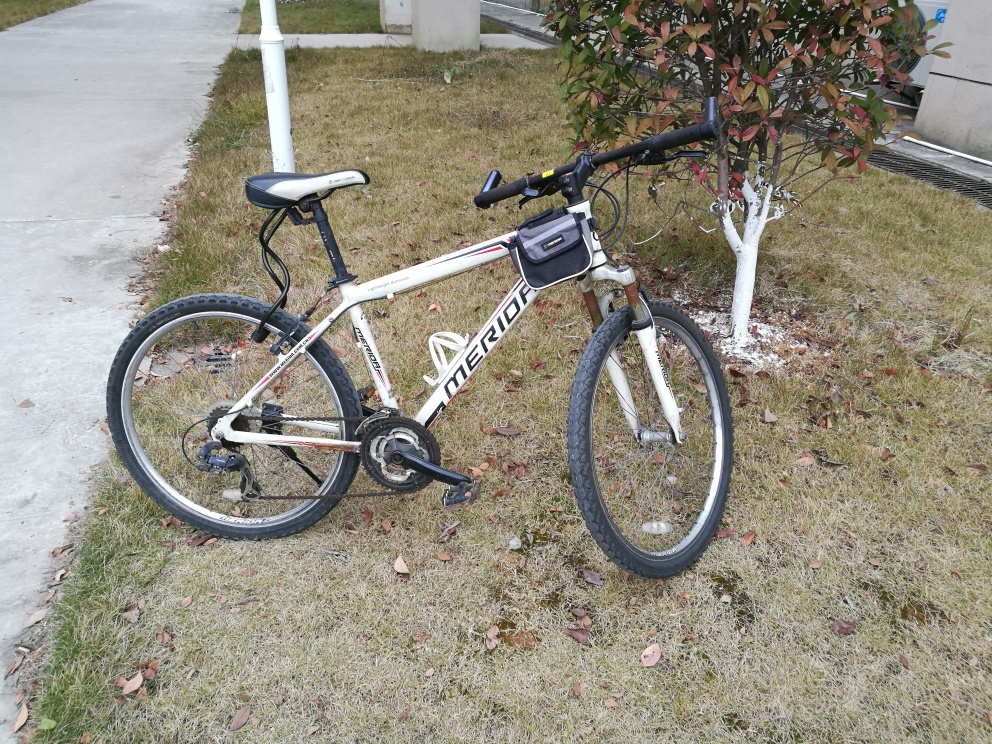Is the clarity of the image good? The clarity of the image is quite satisfactory with ample detail visible. The lighting is even, allowing the viewer to discern features of the bike and the environment. However, for an even clearer understanding, aspects such as the bike's make and condition, or the specific time of day can be discussed. 